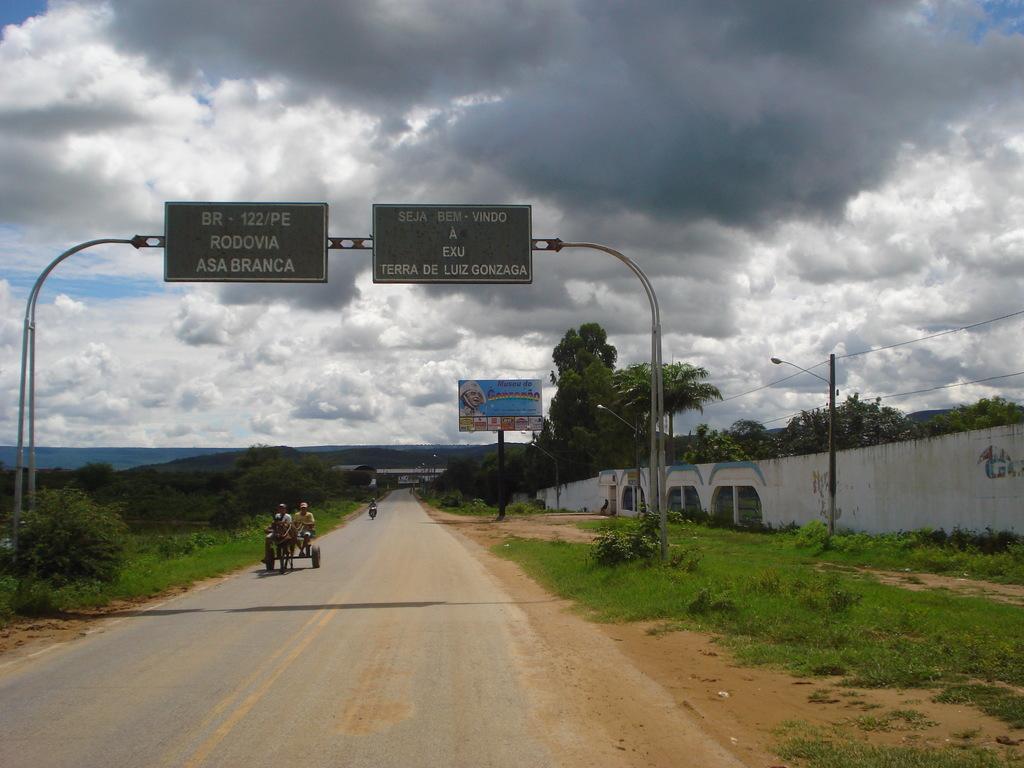What city is up ahead?
Keep it short and to the point. Terra de luiz gonzaga. What are the numbers on the left sign?
Provide a short and direct response. 122. 